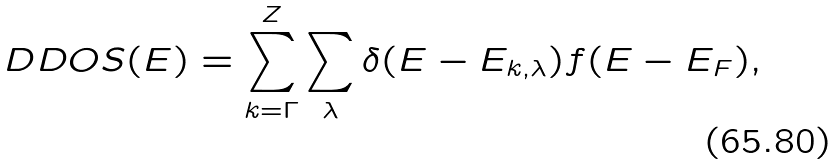Convert formula to latex. <formula><loc_0><loc_0><loc_500><loc_500>D D O S ( E ) = \sum _ { { k } = \Gamma } ^ { Z } \sum _ { \lambda } \delta ( E - E _ { { k } , \lambda } ) f ( E - E _ { F } ) ,</formula> 